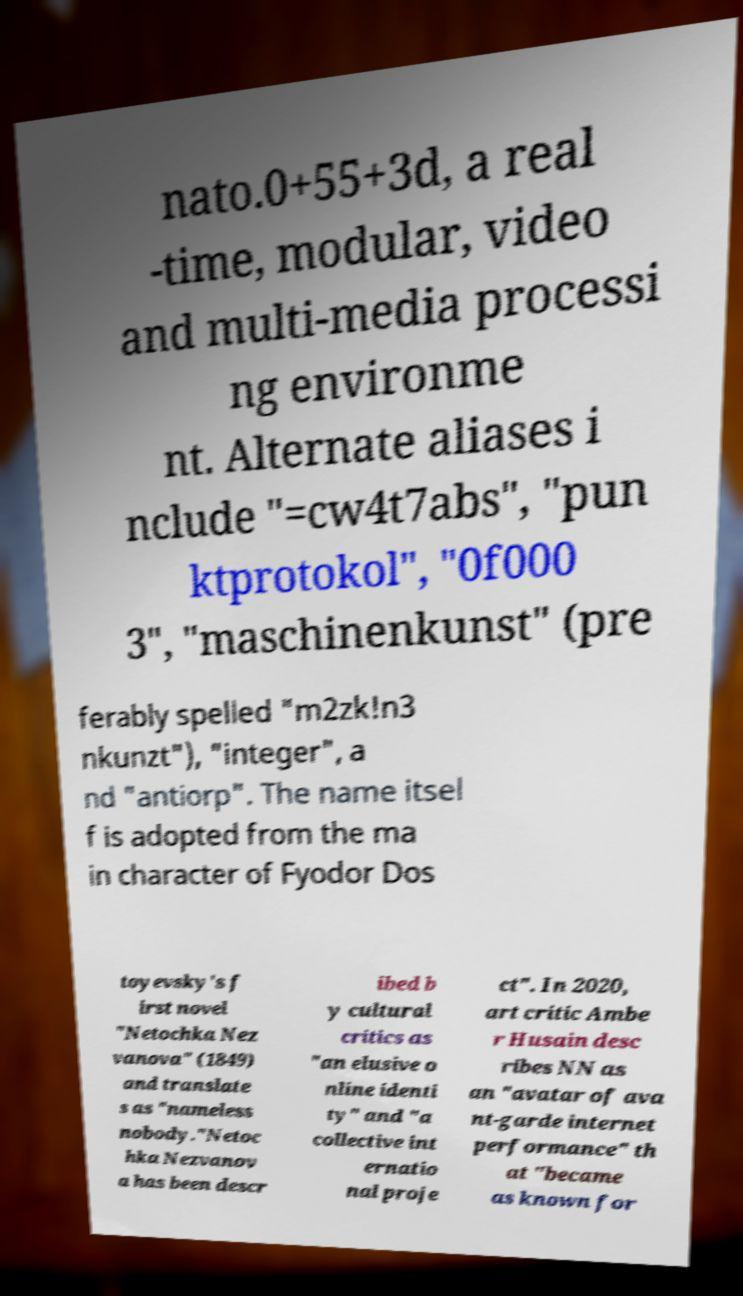Could you assist in decoding the text presented in this image and type it out clearly? nato.0+55+3d, a real -time, modular, video and multi-media processi ng environme nt. Alternate aliases i nclude "=cw4t7abs", "pun ktprotokol", "0f000 3", "maschinenkunst" (pre ferably spelled "m2zk!n3 nkunzt"), "integer", a nd "antiorp". The name itsel f is adopted from the ma in character of Fyodor Dos toyevsky's f irst novel "Netochka Nez vanova" (1849) and translate s as "nameless nobody."Netoc hka Nezvanov a has been descr ibed b y cultural critics as "an elusive o nline identi ty" and "a collective int ernatio nal proje ct". In 2020, art critic Ambe r Husain desc ribes NN as an "avatar of ava nt-garde internet performance" th at "became as known for 